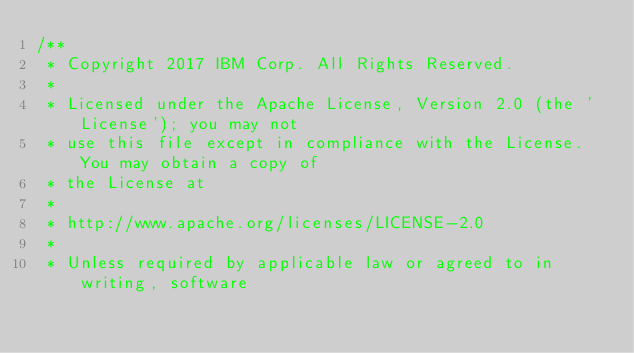<code> <loc_0><loc_0><loc_500><loc_500><_JavaScript_>/**
 * Copyright 2017 IBM Corp. All Rights Reserved.
 *
 * Licensed under the Apache License, Version 2.0 (the 'License'); you may not
 * use this file except in compliance with the License. You may obtain a copy of
 * the License at
 *
 * http://www.apache.org/licenses/LICENSE-2.0
 *
 * Unless required by applicable law or agreed to in writing, software</code> 